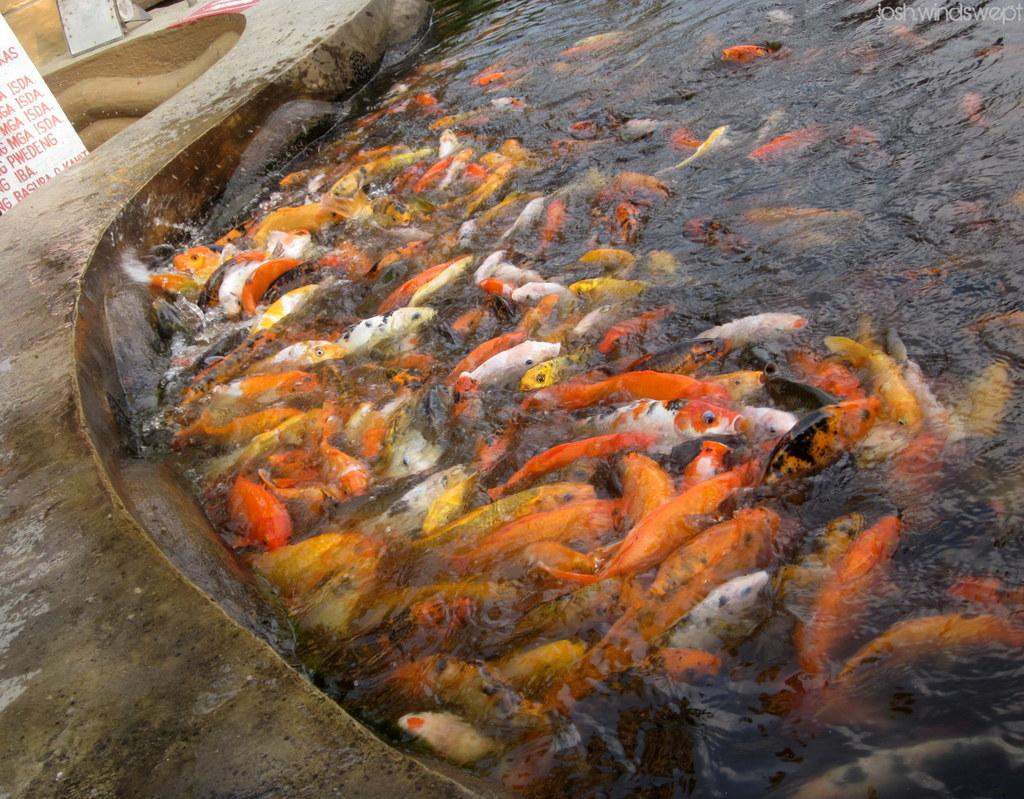What is at the bottom of the image? There is a tank with water at the bottom of the image. What can be seen inside the tank? There are many fishes in the water. What is on the left side of the image? There is a board with text on the left side of the image. What type of cream is being used to express hate in the image? There is no cream or expression of hate present in the image. 